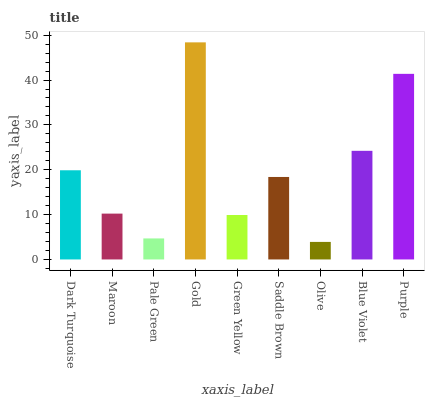Is Maroon the minimum?
Answer yes or no. No. Is Maroon the maximum?
Answer yes or no. No. Is Dark Turquoise greater than Maroon?
Answer yes or no. Yes. Is Maroon less than Dark Turquoise?
Answer yes or no. Yes. Is Maroon greater than Dark Turquoise?
Answer yes or no. No. Is Dark Turquoise less than Maroon?
Answer yes or no. No. Is Saddle Brown the high median?
Answer yes or no. Yes. Is Saddle Brown the low median?
Answer yes or no. Yes. Is Gold the high median?
Answer yes or no. No. Is Maroon the low median?
Answer yes or no. No. 